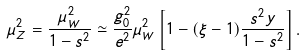<formula> <loc_0><loc_0><loc_500><loc_500>\mu _ { Z } ^ { 2 } = { \frac { \mu _ { W } ^ { 2 } } { 1 - s ^ { 2 } } } \simeq { \frac { g _ { 0 } ^ { 2 } } { e ^ { 2 } } } \mu _ { W } ^ { 2 } \left [ 1 - ( \xi - 1 ) { \frac { s ^ { 2 } y } { 1 - s ^ { 2 } } } \right ] .</formula> 